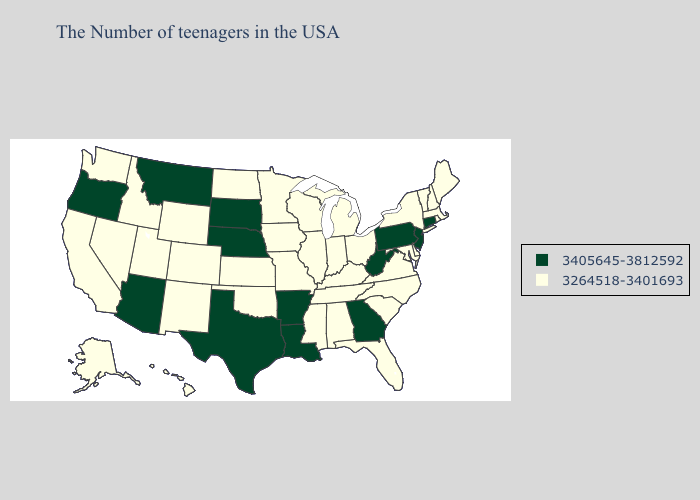Name the states that have a value in the range 3405645-3812592?
Short answer required. Connecticut, New Jersey, Pennsylvania, West Virginia, Georgia, Louisiana, Arkansas, Nebraska, Texas, South Dakota, Montana, Arizona, Oregon. What is the highest value in the USA?
Write a very short answer. 3405645-3812592. Among the states that border Missouri , does Iowa have the highest value?
Be succinct. No. Among the states that border Iowa , does South Dakota have the lowest value?
Be succinct. No. Does West Virginia have the lowest value in the USA?
Give a very brief answer. No. Which states hav the highest value in the South?
Write a very short answer. West Virginia, Georgia, Louisiana, Arkansas, Texas. What is the value of Arizona?
Be succinct. 3405645-3812592. Does Massachusetts have the same value as Michigan?
Quick response, please. Yes. What is the value of Arizona?
Keep it brief. 3405645-3812592. Name the states that have a value in the range 3264518-3401693?
Quick response, please. Maine, Massachusetts, Rhode Island, New Hampshire, Vermont, New York, Delaware, Maryland, Virginia, North Carolina, South Carolina, Ohio, Florida, Michigan, Kentucky, Indiana, Alabama, Tennessee, Wisconsin, Illinois, Mississippi, Missouri, Minnesota, Iowa, Kansas, Oklahoma, North Dakota, Wyoming, Colorado, New Mexico, Utah, Idaho, Nevada, California, Washington, Alaska, Hawaii. What is the value of Texas?
Write a very short answer. 3405645-3812592. What is the value of Nevada?
Answer briefly. 3264518-3401693. Does the first symbol in the legend represent the smallest category?
Write a very short answer. No. Name the states that have a value in the range 3264518-3401693?
Quick response, please. Maine, Massachusetts, Rhode Island, New Hampshire, Vermont, New York, Delaware, Maryland, Virginia, North Carolina, South Carolina, Ohio, Florida, Michigan, Kentucky, Indiana, Alabama, Tennessee, Wisconsin, Illinois, Mississippi, Missouri, Minnesota, Iowa, Kansas, Oklahoma, North Dakota, Wyoming, Colorado, New Mexico, Utah, Idaho, Nevada, California, Washington, Alaska, Hawaii. Name the states that have a value in the range 3405645-3812592?
Answer briefly. Connecticut, New Jersey, Pennsylvania, West Virginia, Georgia, Louisiana, Arkansas, Nebraska, Texas, South Dakota, Montana, Arizona, Oregon. 